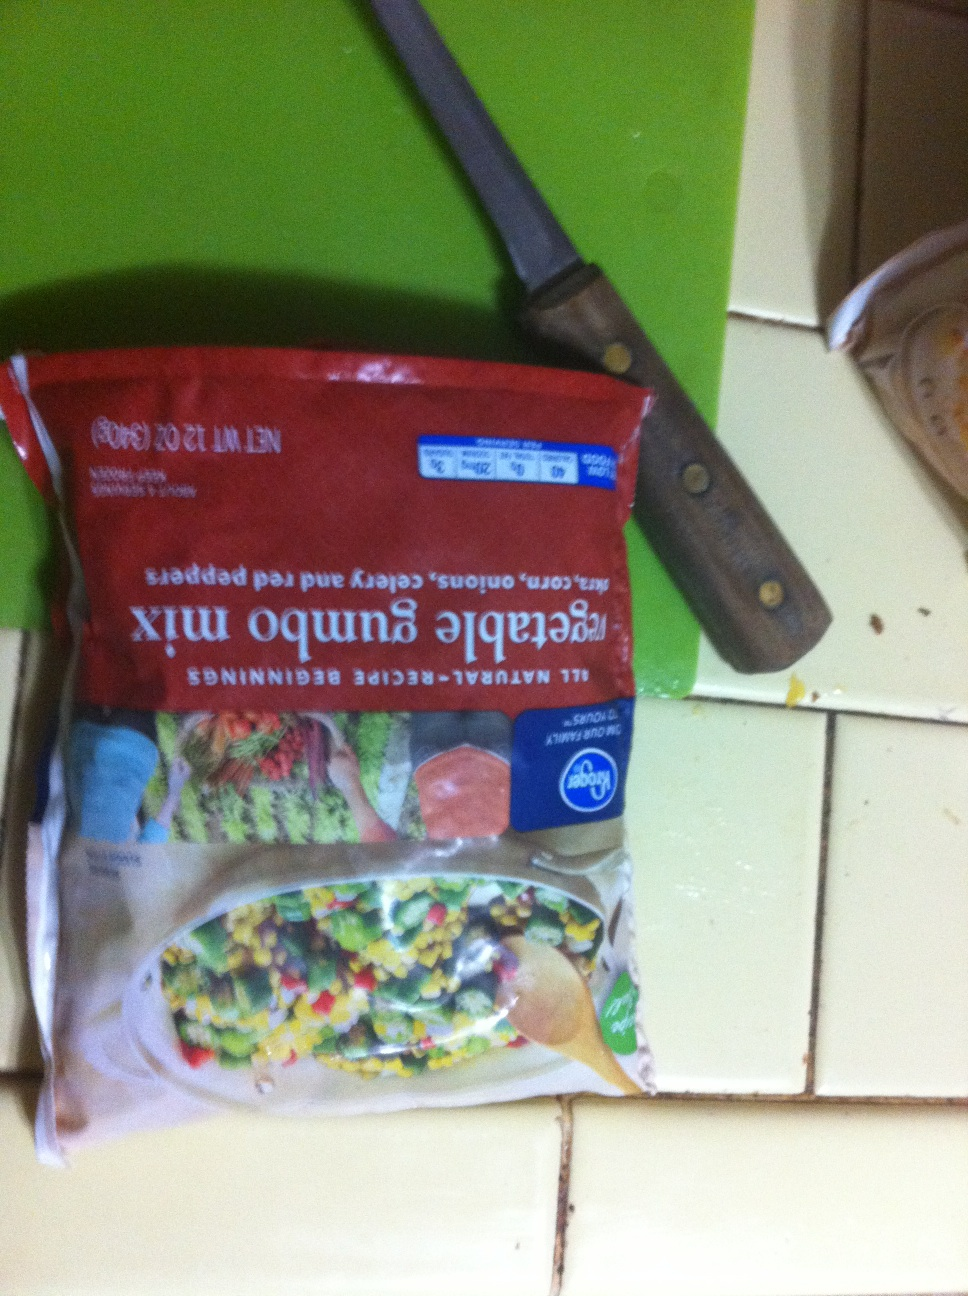Imagine if these vegetables were part of an epic adventure, what role would each vegetable play? Let's imagine! In an epic adventure, the sweet corn kernels could be the wise and ancient scholars of the vegetable kingdom, offering knowledge and wisdom to those who seek it. The onions would be the brave warriors, with layers of courage and strength, ready to fight any battle. Celery would play the role of the swift and agile scouts, providing crucial information from enemy territories. And the red bell peppers would be the vibrant and fiery mages, casting powerful spells to aid their allies. Together, they embark on a quest to save their world from impending doom! 